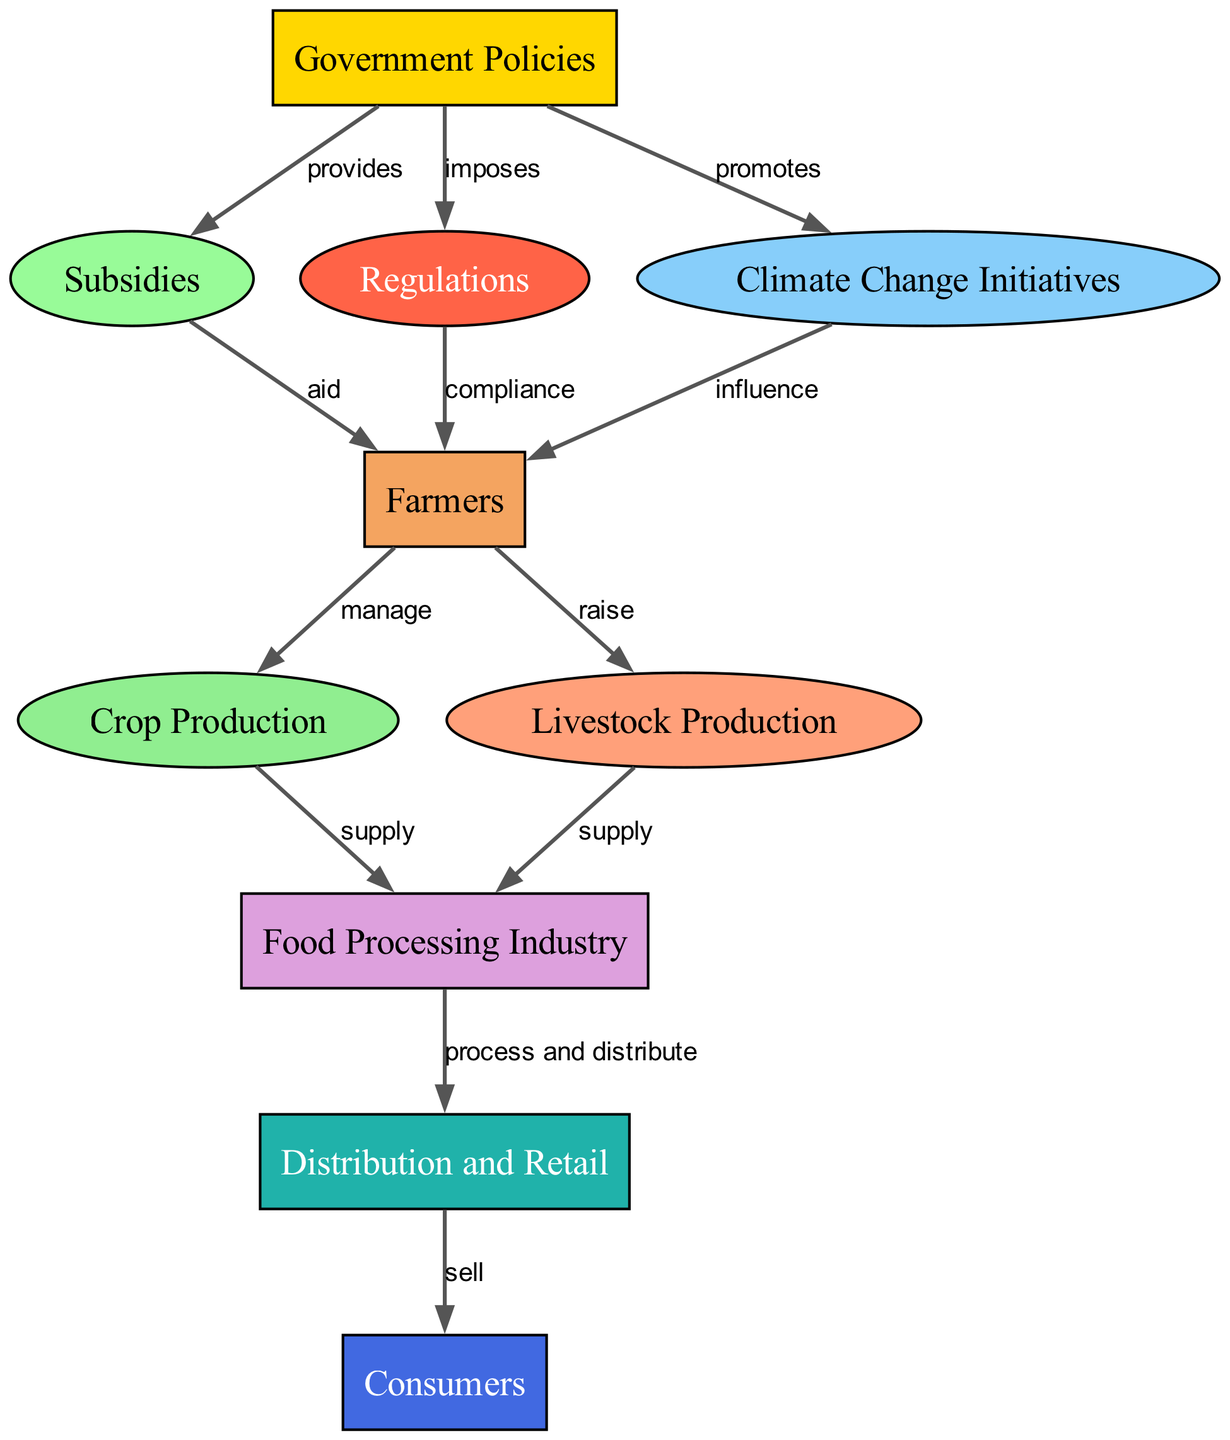What node directly influences farmers? In the diagram, the node labeled "Climate Change Initiatives" is connected to the "Farmers" node with an "influence" relationship, showing that this is the direct connection impacting farmers.
Answer: Climate Change Initiatives How many nodes are there in total? Counting all the unique nodes listed in the diagram, there are ten: Government Policies, Subsidies, Regulations, Climate Change Initiatives, Farmers, Crop Production, Livestock Production, Food Processing Industry, Distribution and Retail, and Consumers.
Answer: 10 What type of aid do subsidies provide to farmers? The relationship between "Subsidies" and "Farmers" is labeled "aid," indicating that subsidies provide financial or resource support to farmers in their agricultural practices.
Answer: aid Which node processes and distributes food? The "Food Processing Industry" node is the one that has a directed edge to the "Distribution and Retail" node with the label "process and distribute," indicating its role in food processing and distribution.
Answer: Food Processing Industry What influences crop production? The "Farmers" node manages both "Crop Production" and "Livestock Production," which means the activities and decisions made by farmers directly influence the levels of crop production.
Answer: Farmers Explain how government policies affect food availability. The flow begins with "Government Policies," which provides "Subsidies" to "Farmers," aiding them to manage "Crop Production" and "Livestock Production." These productions supply the "Food Processing Industry," which then processes and distributes food through "Distribution and Retail," ultimately reaching "Consumers." Therefore, government policies shape the agricultural landscape and food availability by influencing farmer support and production capacities.
Answer: Government Policies Which nodes supply to the food processing industry? The nodes "Crop Production" and "Livestock Production" both connect to "Food Processing Industry," with the relationships labeled "supply," indicating that these productions provide the necessary resources for processing.
Answer: Crop Production and Livestock Production What is the role of regulations in agriculture? Regulations impose requirements on the "Farmers," which means they have to comply with certain standards set by the government, affecting their practices and overall agricultural output.
Answer: compliance What is the end point of the food chain in this diagram? The last node in the diagram is "Consumers," which represents the final stage where the processed food reaches the market for consumption.
Answer: Consumers 